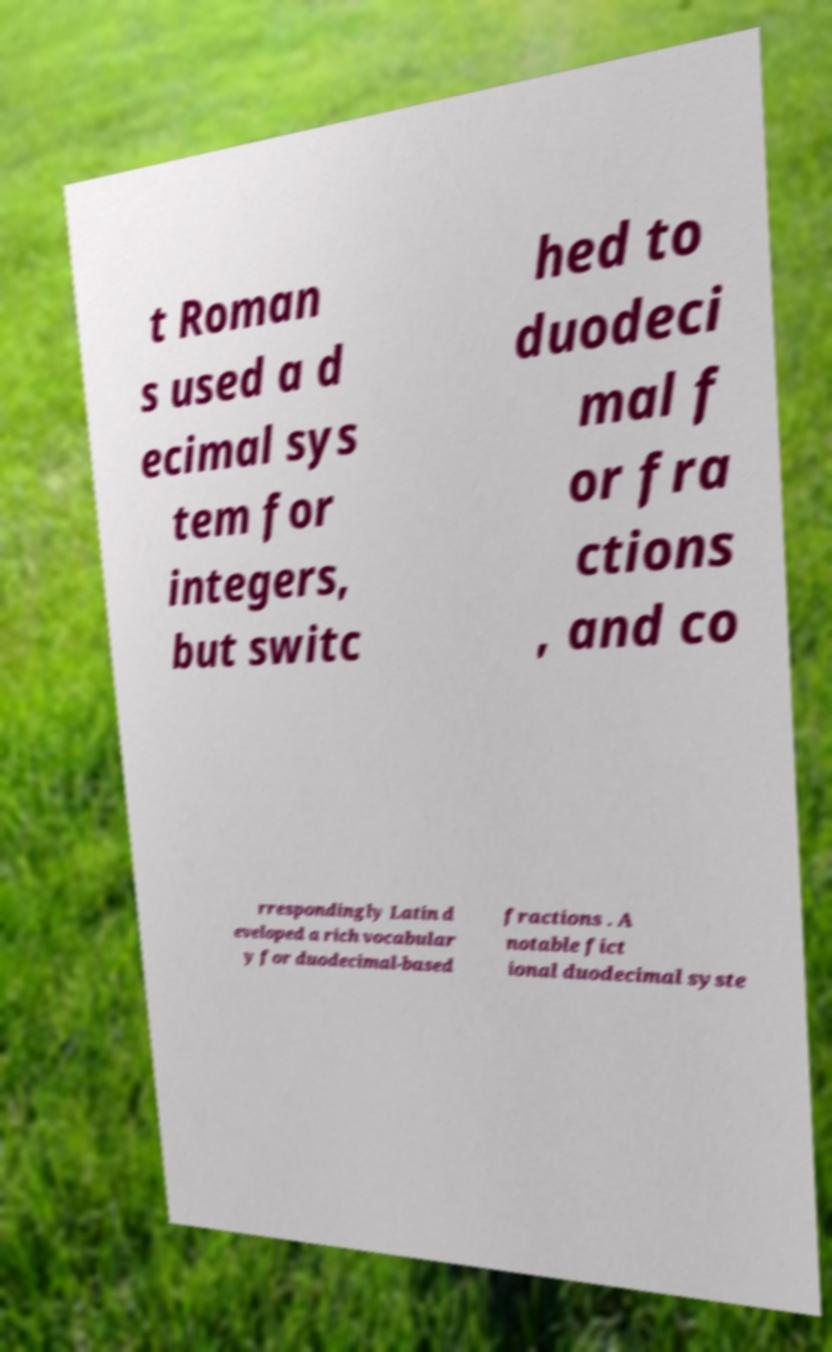There's text embedded in this image that I need extracted. Can you transcribe it verbatim? t Roman s used a d ecimal sys tem for integers, but switc hed to duodeci mal f or fra ctions , and co rrespondingly Latin d eveloped a rich vocabular y for duodecimal-based fractions . A notable fict ional duodecimal syste 